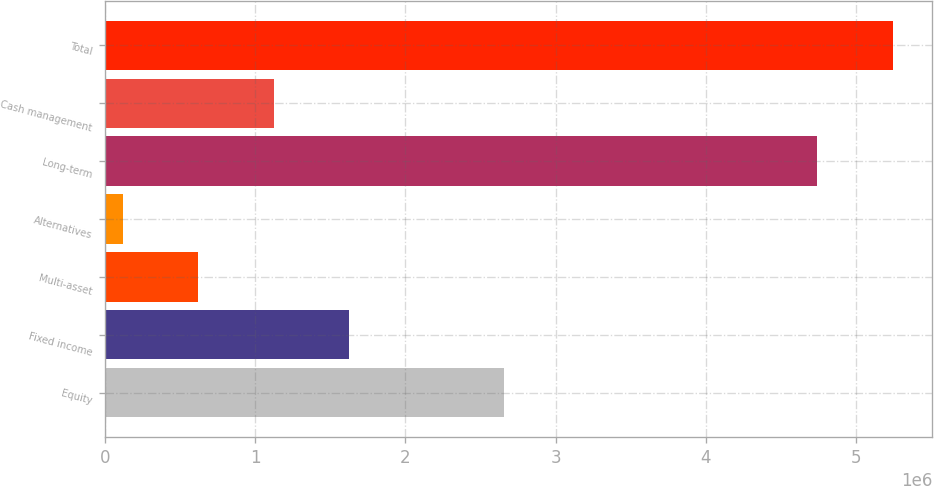Convert chart to OTSL. <chart><loc_0><loc_0><loc_500><loc_500><bar_chart><fcel>Equity<fcel>Fixed income<fcel>Multi-asset<fcel>Alternatives<fcel>Long-term<fcel>Cash management<fcel>Total<nl><fcel>2.65718e+06<fcel>1.62621e+06<fcel>620029<fcel>116938<fcel>4.74149e+06<fcel>1.12312e+06<fcel>5.24458e+06<nl></chart> 